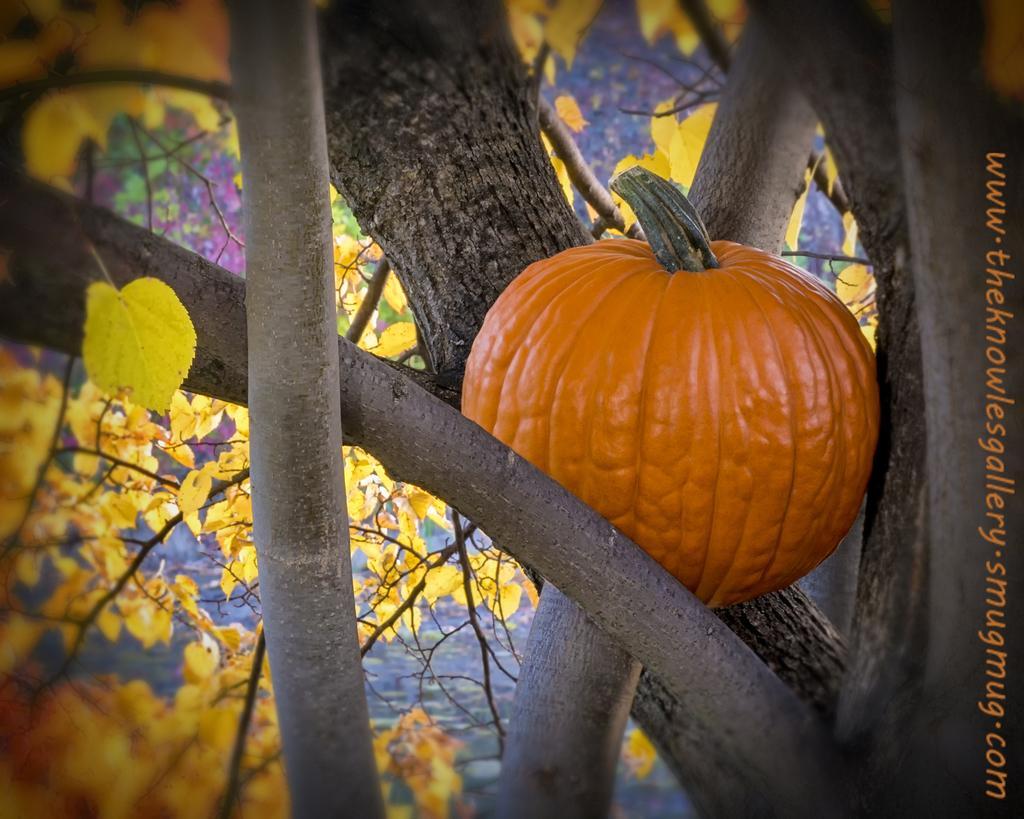Could you give a brief overview of what you see in this image? This is a pumpkin which is in orange color in the branches of a tree. In the left side these are the leaves. 